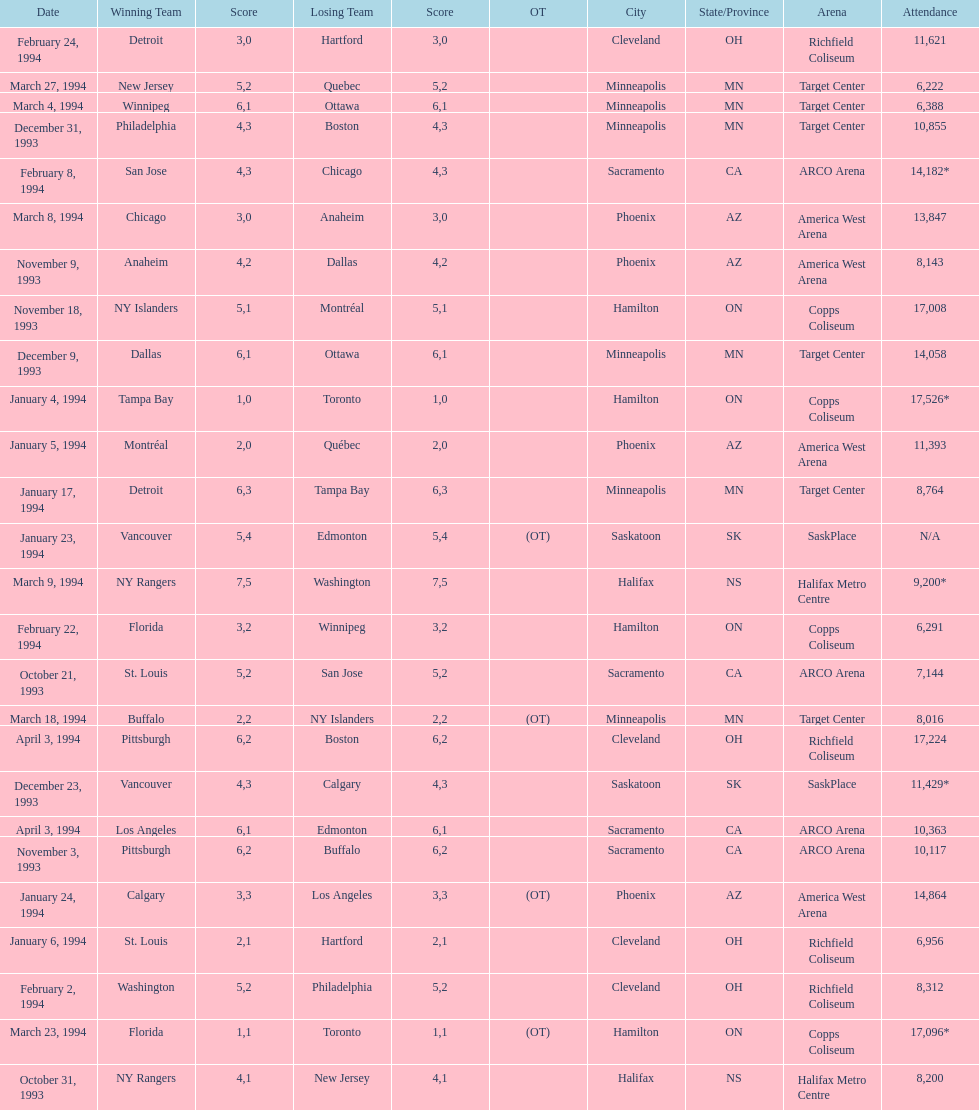How many events occurred in minneapolis, mn? 6. 